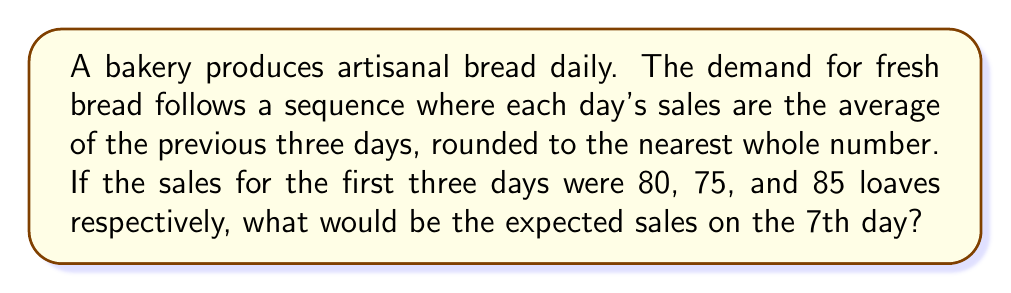Could you help me with this problem? Let's solve this step-by-step:

1) First, let's list out the known sales:
   Day 1: 80
   Day 2: 75
   Day 3: 85

2) To find Day 4 sales, we average the previous three days:
   Day 4 = $\frac{80 + 75 + 85}{3} = 80$ loaves

3) For Day 5:
   Day 5 = $\frac{75 + 85 + 80}{3} = 80$ loaves

4) For Day 6:
   Day 6 = $\frac{85 + 80 + 80}{3} = 81.67$, rounded to 82 loaves

5) Finally, for Day 7:
   Day 7 = $\frac{80 + 80 + 82}{3} = 80.67$, rounded to 81 loaves

Therefore, the expected sales on the 7th day would be 81 loaves.
Answer: 81 loaves 